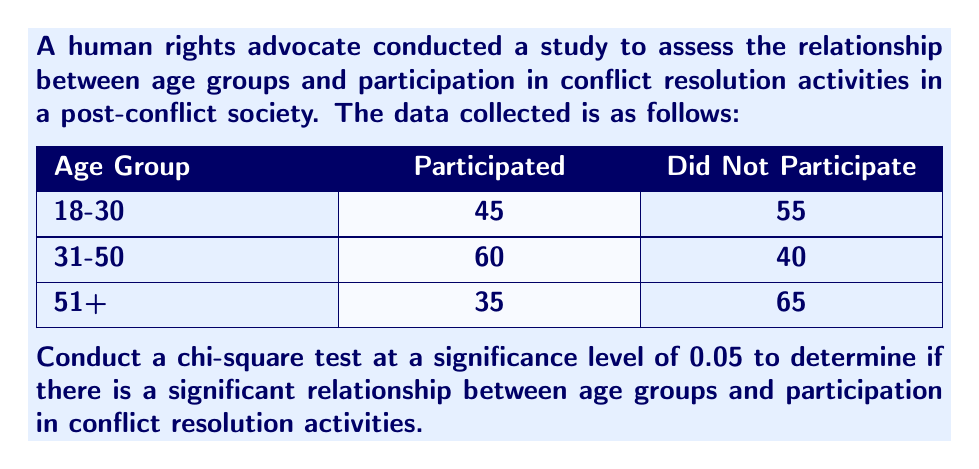Help me with this question. To conduct a chi-square test, we'll follow these steps:

1. State the hypotheses:
   $H_0$: There is no relationship between age groups and participation in conflict resolution activities.
   $H_1$: There is a relationship between age groups and participation in conflict resolution activities.

2. Calculate the expected frequencies:
   Total participants: 45 + 60 + 35 + 55 + 40 + 65 = 300
   
   Expected frequencies:
   18-30, Participated: $\frac{100 \times 140}{300} = 46.67$
   18-30, Did Not Participate: $\frac{100 \times 160}{300} = 53.33$
   31-50, Participated: $\frac{100 \times 140}{300} = 46.67$
   31-50, Did Not Participate: $\frac{100 \times 160}{300} = 53.33$
   51+, Participated: $\frac{100 \times 140}{300} = 46.67$
   51+, Did Not Participate: $\frac{100 \times 160}{300} = 53.33$

3. Calculate the chi-square statistic:
   $$\chi^2 = \sum \frac{(O - E)^2}{E}$$
   
   $\chi^2 = \frac{(45 - 46.67)^2}{46.67} + \frac{(55 - 53.33)^2}{53.33} + \frac{(60 - 46.67)^2}{46.67} + \frac{(40 - 53.33)^2}{53.33} + \frac{(35 - 46.67)^2}{46.67} + \frac{(65 - 53.33)^2}{53.33}$
   
   $\chi^2 = 0.06 + 0.05 + 3.80 + 3.33 + 2.92 + 2.55 = 12.71$

4. Determine the degrees of freedom:
   df = (rows - 1) × (columns - 1) = (3 - 1) × (2 - 1) = 2

5. Find the critical value:
   For α = 0.05 and df = 2, the critical value is 5.991

6. Compare the chi-square statistic to the critical value:
   Since $12.71 > 5.991$, we reject the null hypothesis.

7. Calculate the p-value:
   Using a chi-square distribution calculator, we find that the p-value for $\chi^2 = 12.71$ with df = 2 is approximately 0.0017.
Answer: Reject $H_0$; there is a significant relationship between age groups and participation in conflict resolution activities (χ² = 12.71, df = 2, p = 0.0017). 